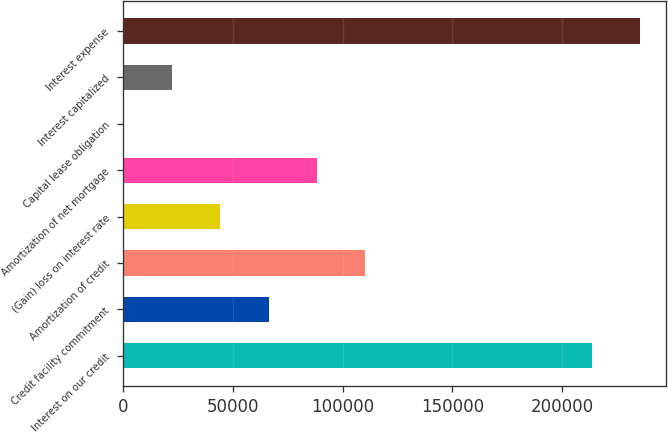<chart> <loc_0><loc_0><loc_500><loc_500><bar_chart><fcel>Interest on our credit<fcel>Credit facility commitment<fcel>Amortization of credit<fcel>(Gain) loss on interest rate<fcel>Amortization of net mortgage<fcel>Capital lease obligation<fcel>Interest capitalized<fcel>Interest expense<nl><fcel>213540<fcel>66209.2<fcel>110142<fcel>44242.8<fcel>88175.6<fcel>310<fcel>22276.4<fcel>235506<nl></chart> 